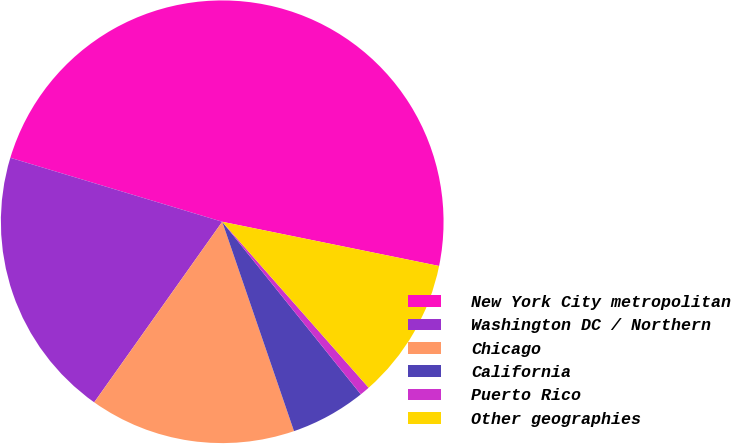Convert chart. <chart><loc_0><loc_0><loc_500><loc_500><pie_chart><fcel>New York City metropolitan<fcel>Washington DC / Northern<fcel>Chicago<fcel>California<fcel>Puerto Rico<fcel>Other geographies<nl><fcel>48.53%<fcel>19.85%<fcel>15.07%<fcel>5.51%<fcel>0.74%<fcel>10.29%<nl></chart> 